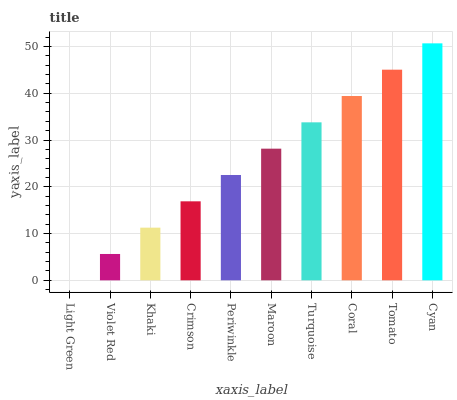Is Light Green the minimum?
Answer yes or no. Yes. Is Cyan the maximum?
Answer yes or no. Yes. Is Violet Red the minimum?
Answer yes or no. No. Is Violet Red the maximum?
Answer yes or no. No. Is Violet Red greater than Light Green?
Answer yes or no. Yes. Is Light Green less than Violet Red?
Answer yes or no. Yes. Is Light Green greater than Violet Red?
Answer yes or no. No. Is Violet Red less than Light Green?
Answer yes or no. No. Is Maroon the high median?
Answer yes or no. Yes. Is Periwinkle the low median?
Answer yes or no. Yes. Is Light Green the high median?
Answer yes or no. No. Is Khaki the low median?
Answer yes or no. No. 